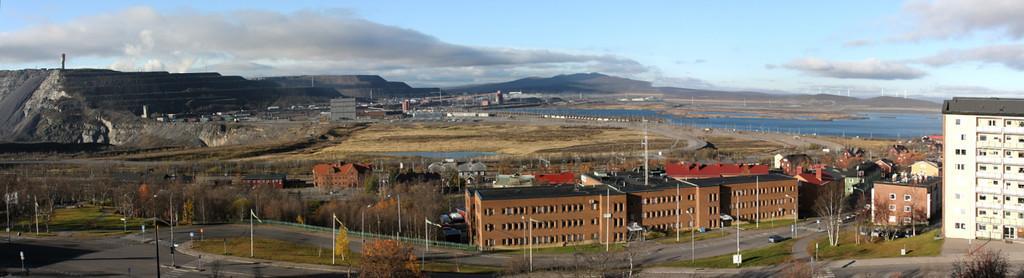Describe this image in one or two sentences. In this image I can see the vehicles on the road. On both sides of the road I can see the many poles, trees and the buildings with windows. In the background I can see the water, few more buildings and mountains. I can also see the clouds and the sky in the back. 